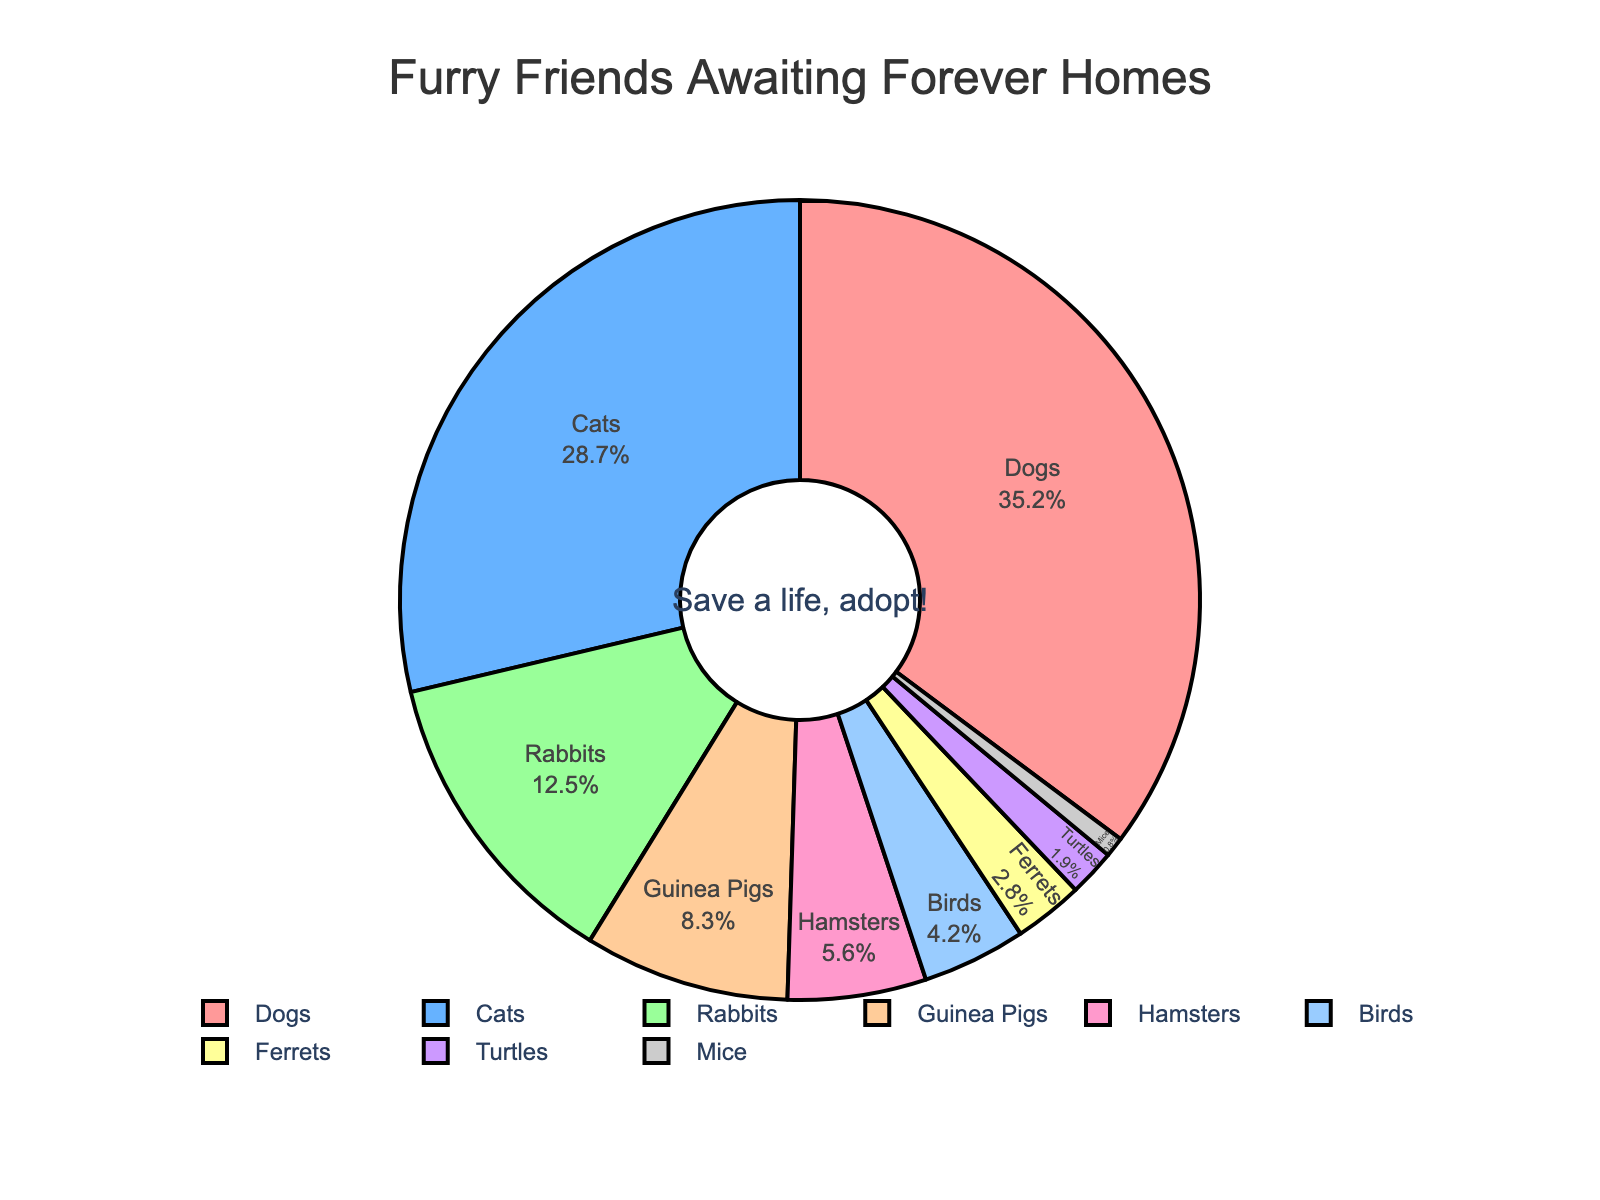Which animal species have the largest and smallest proportions in local shelters? The figure shows each species' label and percentage inside segments. The species with the largest proportion is Dogs at 35.2%, and the smallest is Mice at 0.8%.
Answer: Dogs and Mice What is the combined percentage of Dogs and Cats awaiting adoption? To find the combined percentage, sum the percentages of Dogs and Cats: 35.2% + 28.7% = 63.9%.
Answer: 63.9% Are there more Dogs or combined Rabbits and Guinea Pigs in the shelters? Compare the percentage of Dogs (35.2%) with the sum of Rabbits (12.5%) and Guinea Pigs (8.3%): 12.5% + 8.3% = 20.8%. 35.2% is greater than 20.8%.
Answer: Dogs What is the difference in percentage between Cats and Birds? Subtract Birds' percentage from Cats': 28.7% - 4.2% = 24.5%.
Answer: 24.5% Which animal species is represented by a purple color in the pie chart? The pie chart assigns specific colors to each segment. The natural language description indicates a purple color, which corresponds to Turtles with 1.9%.
Answer: Turtles What percentage of animals in local shelters are small mammals like Rabbits, Guinea Pigs, and Hamsters combined? To find this, sum their percentages: Rabbits (12.5%) + Guinea Pigs (8.3%) + Hamsters (5.6%) = 26.4%.
Answer: 26.4% Are there fewer Birds or Ferrets awaiting adoption? Compare the percentages of Birds (4.2%) and Ferrets (2.8%). 2.8% (Ferrets) is less than 4.2% (Birds).
Answer: Ferrets How many species have a percentage greater than 10%? Look at the percentages for each species. Dogs, Cats, and Rabbits have percentages greater than 10%. That totals 3 species.
Answer: 3 What is the sum of the percentages for the least common three species? Add the percentages for Turtles (1.9%), Mice (0.8%), and Ferrets (2.8%): 1.9% + 0.8% + 2.8% = 5.5%.
Answer: 5.5% Among the listed animals, which two species have the most similar percentage of representation in the shelters? Compare the percentages to find the closest values. Hamsters (5.6%) and Birds (4.2%) are closest: 5.6% - 4.2% = 1.4%.
Answer: Hamsters and Birds 